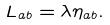<formula> <loc_0><loc_0><loc_500><loc_500>L _ { a b } = \lambda \eta _ { a b } .</formula> 